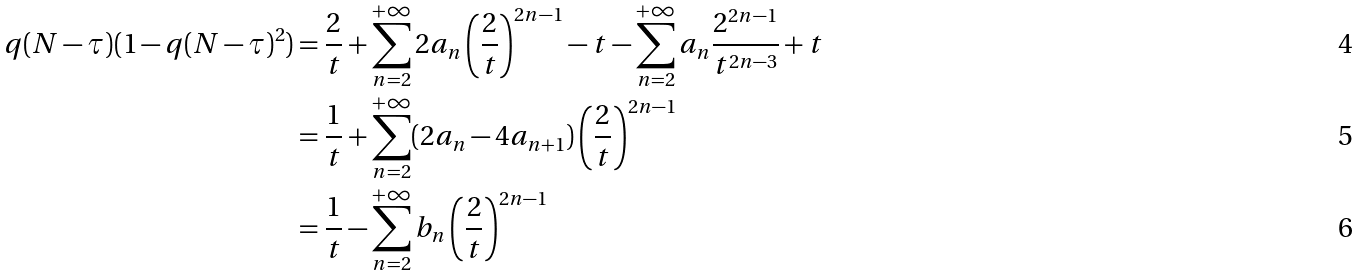Convert formula to latex. <formula><loc_0><loc_0><loc_500><loc_500>q ( N - \tau ) ( 1 - q ( N - \tau ) ^ { 2 } ) & = \frac { 2 } { t } + \sum _ { n = 2 } ^ { + \infty } 2 a _ { n } \left ( \frac { 2 } { t } \right ) ^ { 2 n - 1 } - t - \sum _ { n = 2 } ^ { + \infty } a _ { n } \frac { 2 ^ { 2 n - 1 } } { t ^ { 2 n - 3 } } + t \\ & = \frac { 1 } { t } + \sum _ { n = 2 } ^ { + \infty } ( 2 a _ { n } - 4 a _ { n + 1 } ) \left ( \frac { 2 } { t } \right ) ^ { 2 n - 1 } \\ & = \frac { 1 } { t } - \sum _ { n = 2 } ^ { + \infty } b _ { n } \left ( \frac { 2 } { t } \right ) ^ { 2 n - 1 }</formula> 